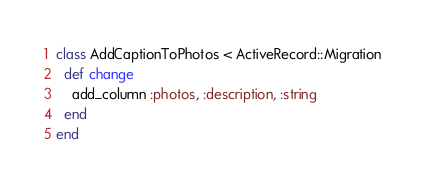Convert code to text. <code><loc_0><loc_0><loc_500><loc_500><_Ruby_>class AddCaptionToPhotos < ActiveRecord::Migration
  def change
    add_column :photos, :description, :string
  end
end
</code> 